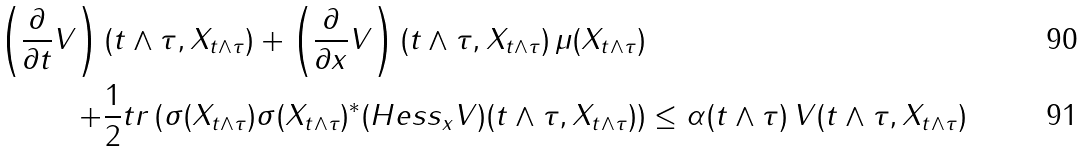Convert formula to latex. <formula><loc_0><loc_0><loc_500><loc_500>\left ( \frac { \partial } { \partial t } V \right ) ( t \wedge \tau , X _ { t \wedge \tau } ) + \left ( \frac { \partial } { \partial x } V \right ) ( t \wedge \tau , X _ { t \wedge \tau } ) \, \mu ( X _ { t \wedge \tau } ) \\ + \frac { 1 } { 2 } t r \left ( \sigma ( X _ { t \wedge \tau } ) \sigma ( X _ { t \wedge \tau } ) ^ { * } ( H e s s _ { x } V ) ( t \wedge \tau , X _ { t \wedge \tau } ) \right ) & \leq \alpha ( t \wedge \tau ) \, V ( t \wedge \tau , X _ { t \wedge \tau } )</formula> 